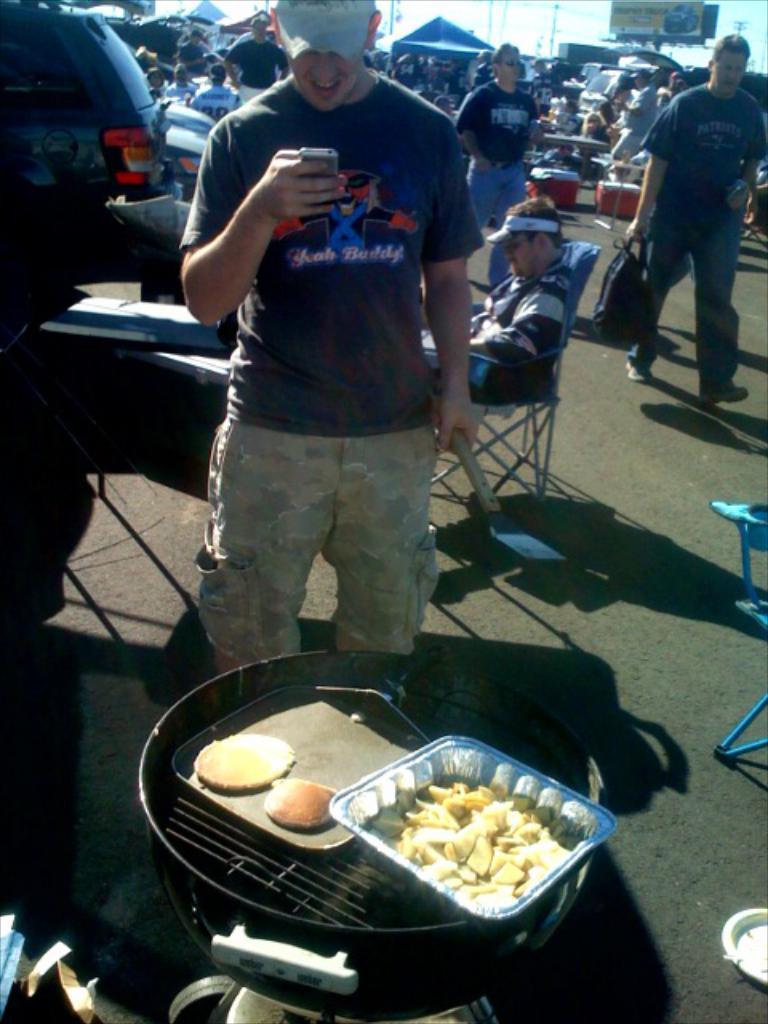Please provide a concise description of this image. In this picture i can see group of people among them few are standing and few are sitting on chairs. I can also see food items on an object, shadows, vehicles and other objects on the ground. In the background i can see sky, houses and poles. 